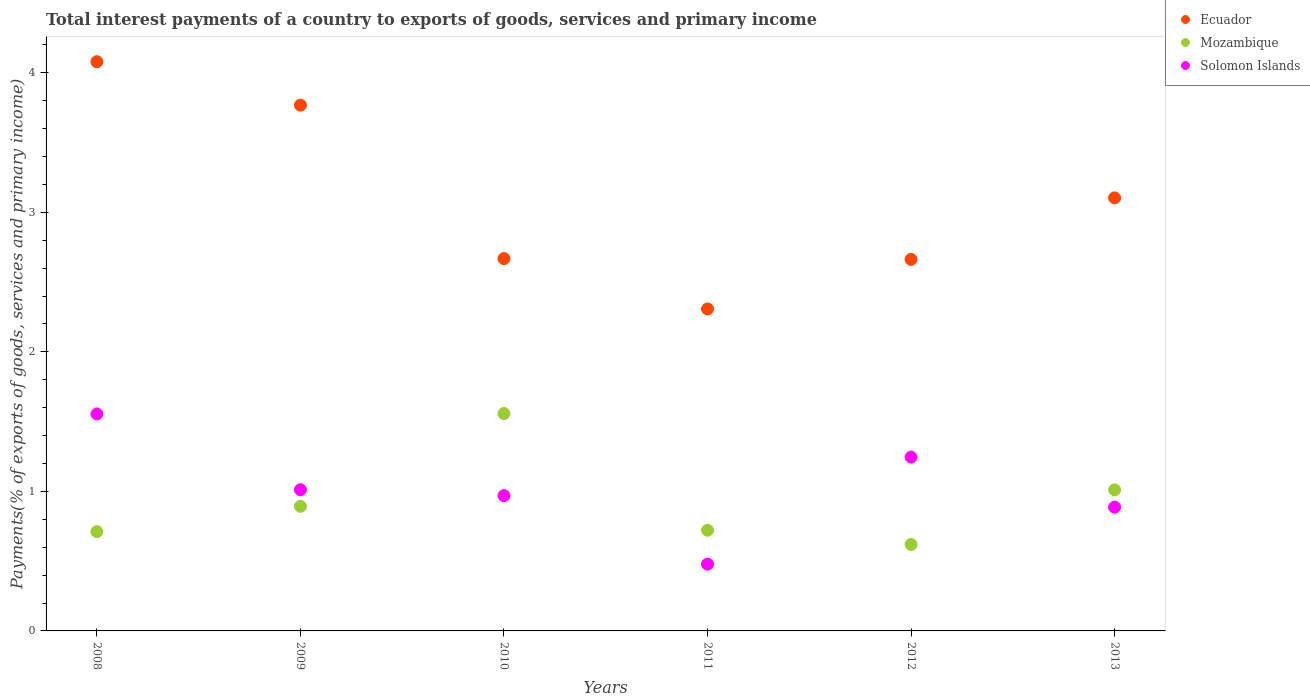Is the number of dotlines equal to the number of legend labels?
Provide a short and direct response. Yes. What is the total interest payments in Mozambique in 2010?
Your answer should be very brief. 1.56. Across all years, what is the maximum total interest payments in Solomon Islands?
Offer a very short reply. 1.56. Across all years, what is the minimum total interest payments in Solomon Islands?
Make the answer very short. 0.48. In which year was the total interest payments in Mozambique maximum?
Your answer should be compact. 2010. What is the total total interest payments in Solomon Islands in the graph?
Provide a short and direct response. 6.15. What is the difference between the total interest payments in Ecuador in 2010 and that in 2012?
Your answer should be very brief. 0.01. What is the difference between the total interest payments in Ecuador in 2009 and the total interest payments in Mozambique in 2012?
Give a very brief answer. 3.15. What is the average total interest payments in Mozambique per year?
Give a very brief answer. 0.92. In the year 2013, what is the difference between the total interest payments in Mozambique and total interest payments in Ecuador?
Provide a succinct answer. -2.09. In how many years, is the total interest payments in Mozambique greater than 0.8 %?
Give a very brief answer. 3. What is the ratio of the total interest payments in Ecuador in 2010 to that in 2013?
Your answer should be very brief. 0.86. Is the total interest payments in Ecuador in 2008 less than that in 2011?
Offer a terse response. No. Is the difference between the total interest payments in Mozambique in 2011 and 2013 greater than the difference between the total interest payments in Ecuador in 2011 and 2013?
Offer a terse response. Yes. What is the difference between the highest and the second highest total interest payments in Solomon Islands?
Keep it short and to the point. 0.31. What is the difference between the highest and the lowest total interest payments in Mozambique?
Your answer should be compact. 0.94. In how many years, is the total interest payments in Mozambique greater than the average total interest payments in Mozambique taken over all years?
Provide a short and direct response. 2. Is the sum of the total interest payments in Solomon Islands in 2008 and 2013 greater than the maximum total interest payments in Mozambique across all years?
Provide a short and direct response. Yes. Is the total interest payments in Solomon Islands strictly greater than the total interest payments in Ecuador over the years?
Keep it short and to the point. No. How many dotlines are there?
Provide a short and direct response. 3. How many years are there in the graph?
Offer a terse response. 6. Are the values on the major ticks of Y-axis written in scientific E-notation?
Ensure brevity in your answer.  No. Does the graph contain any zero values?
Provide a succinct answer. No. Where does the legend appear in the graph?
Offer a terse response. Top right. What is the title of the graph?
Ensure brevity in your answer.  Total interest payments of a country to exports of goods, services and primary income. What is the label or title of the Y-axis?
Provide a succinct answer. Payments(% of exports of goods, services and primary income). What is the Payments(% of exports of goods, services and primary income) of Ecuador in 2008?
Provide a succinct answer. 4.08. What is the Payments(% of exports of goods, services and primary income) of Mozambique in 2008?
Your response must be concise. 0.71. What is the Payments(% of exports of goods, services and primary income) in Solomon Islands in 2008?
Ensure brevity in your answer.  1.56. What is the Payments(% of exports of goods, services and primary income) in Ecuador in 2009?
Offer a terse response. 3.77. What is the Payments(% of exports of goods, services and primary income) in Mozambique in 2009?
Your answer should be very brief. 0.89. What is the Payments(% of exports of goods, services and primary income) of Solomon Islands in 2009?
Keep it short and to the point. 1.01. What is the Payments(% of exports of goods, services and primary income) in Ecuador in 2010?
Keep it short and to the point. 2.67. What is the Payments(% of exports of goods, services and primary income) in Mozambique in 2010?
Your answer should be compact. 1.56. What is the Payments(% of exports of goods, services and primary income) of Solomon Islands in 2010?
Give a very brief answer. 0.97. What is the Payments(% of exports of goods, services and primary income) in Ecuador in 2011?
Offer a terse response. 2.31. What is the Payments(% of exports of goods, services and primary income) in Mozambique in 2011?
Give a very brief answer. 0.72. What is the Payments(% of exports of goods, services and primary income) of Solomon Islands in 2011?
Offer a terse response. 0.48. What is the Payments(% of exports of goods, services and primary income) of Ecuador in 2012?
Provide a succinct answer. 2.66. What is the Payments(% of exports of goods, services and primary income) in Mozambique in 2012?
Offer a very short reply. 0.62. What is the Payments(% of exports of goods, services and primary income) in Solomon Islands in 2012?
Make the answer very short. 1.25. What is the Payments(% of exports of goods, services and primary income) in Ecuador in 2013?
Provide a succinct answer. 3.1. What is the Payments(% of exports of goods, services and primary income) of Mozambique in 2013?
Your answer should be very brief. 1.01. What is the Payments(% of exports of goods, services and primary income) in Solomon Islands in 2013?
Offer a very short reply. 0.89. Across all years, what is the maximum Payments(% of exports of goods, services and primary income) of Ecuador?
Keep it short and to the point. 4.08. Across all years, what is the maximum Payments(% of exports of goods, services and primary income) of Mozambique?
Offer a terse response. 1.56. Across all years, what is the maximum Payments(% of exports of goods, services and primary income) of Solomon Islands?
Provide a succinct answer. 1.56. Across all years, what is the minimum Payments(% of exports of goods, services and primary income) in Ecuador?
Offer a very short reply. 2.31. Across all years, what is the minimum Payments(% of exports of goods, services and primary income) of Mozambique?
Provide a succinct answer. 0.62. Across all years, what is the minimum Payments(% of exports of goods, services and primary income) in Solomon Islands?
Give a very brief answer. 0.48. What is the total Payments(% of exports of goods, services and primary income) in Ecuador in the graph?
Give a very brief answer. 18.59. What is the total Payments(% of exports of goods, services and primary income) of Mozambique in the graph?
Your answer should be very brief. 5.51. What is the total Payments(% of exports of goods, services and primary income) in Solomon Islands in the graph?
Provide a succinct answer. 6.15. What is the difference between the Payments(% of exports of goods, services and primary income) of Ecuador in 2008 and that in 2009?
Your response must be concise. 0.31. What is the difference between the Payments(% of exports of goods, services and primary income) in Mozambique in 2008 and that in 2009?
Offer a very short reply. -0.18. What is the difference between the Payments(% of exports of goods, services and primary income) of Solomon Islands in 2008 and that in 2009?
Make the answer very short. 0.54. What is the difference between the Payments(% of exports of goods, services and primary income) in Ecuador in 2008 and that in 2010?
Make the answer very short. 1.41. What is the difference between the Payments(% of exports of goods, services and primary income) in Mozambique in 2008 and that in 2010?
Offer a very short reply. -0.85. What is the difference between the Payments(% of exports of goods, services and primary income) in Solomon Islands in 2008 and that in 2010?
Ensure brevity in your answer.  0.59. What is the difference between the Payments(% of exports of goods, services and primary income) in Ecuador in 2008 and that in 2011?
Provide a short and direct response. 1.77. What is the difference between the Payments(% of exports of goods, services and primary income) of Mozambique in 2008 and that in 2011?
Provide a succinct answer. -0.01. What is the difference between the Payments(% of exports of goods, services and primary income) of Solomon Islands in 2008 and that in 2011?
Offer a terse response. 1.08. What is the difference between the Payments(% of exports of goods, services and primary income) in Ecuador in 2008 and that in 2012?
Offer a terse response. 1.42. What is the difference between the Payments(% of exports of goods, services and primary income) of Mozambique in 2008 and that in 2012?
Ensure brevity in your answer.  0.09. What is the difference between the Payments(% of exports of goods, services and primary income) of Solomon Islands in 2008 and that in 2012?
Your answer should be compact. 0.31. What is the difference between the Payments(% of exports of goods, services and primary income) in Mozambique in 2008 and that in 2013?
Make the answer very short. -0.3. What is the difference between the Payments(% of exports of goods, services and primary income) of Solomon Islands in 2008 and that in 2013?
Your answer should be very brief. 0.67. What is the difference between the Payments(% of exports of goods, services and primary income) of Ecuador in 2009 and that in 2010?
Provide a succinct answer. 1.1. What is the difference between the Payments(% of exports of goods, services and primary income) in Mozambique in 2009 and that in 2010?
Your answer should be very brief. -0.67. What is the difference between the Payments(% of exports of goods, services and primary income) of Solomon Islands in 2009 and that in 2010?
Your answer should be compact. 0.04. What is the difference between the Payments(% of exports of goods, services and primary income) in Ecuador in 2009 and that in 2011?
Your answer should be very brief. 1.46. What is the difference between the Payments(% of exports of goods, services and primary income) in Mozambique in 2009 and that in 2011?
Your response must be concise. 0.17. What is the difference between the Payments(% of exports of goods, services and primary income) in Solomon Islands in 2009 and that in 2011?
Provide a short and direct response. 0.53. What is the difference between the Payments(% of exports of goods, services and primary income) of Ecuador in 2009 and that in 2012?
Offer a terse response. 1.11. What is the difference between the Payments(% of exports of goods, services and primary income) in Mozambique in 2009 and that in 2012?
Provide a short and direct response. 0.27. What is the difference between the Payments(% of exports of goods, services and primary income) in Solomon Islands in 2009 and that in 2012?
Provide a succinct answer. -0.23. What is the difference between the Payments(% of exports of goods, services and primary income) of Ecuador in 2009 and that in 2013?
Give a very brief answer. 0.66. What is the difference between the Payments(% of exports of goods, services and primary income) in Mozambique in 2009 and that in 2013?
Make the answer very short. -0.12. What is the difference between the Payments(% of exports of goods, services and primary income) of Solomon Islands in 2009 and that in 2013?
Your response must be concise. 0.12. What is the difference between the Payments(% of exports of goods, services and primary income) of Ecuador in 2010 and that in 2011?
Your answer should be compact. 0.36. What is the difference between the Payments(% of exports of goods, services and primary income) of Mozambique in 2010 and that in 2011?
Make the answer very short. 0.84. What is the difference between the Payments(% of exports of goods, services and primary income) in Solomon Islands in 2010 and that in 2011?
Provide a succinct answer. 0.49. What is the difference between the Payments(% of exports of goods, services and primary income) of Ecuador in 2010 and that in 2012?
Your answer should be compact. 0.01. What is the difference between the Payments(% of exports of goods, services and primary income) of Mozambique in 2010 and that in 2012?
Keep it short and to the point. 0.94. What is the difference between the Payments(% of exports of goods, services and primary income) in Solomon Islands in 2010 and that in 2012?
Offer a terse response. -0.28. What is the difference between the Payments(% of exports of goods, services and primary income) in Ecuador in 2010 and that in 2013?
Give a very brief answer. -0.44. What is the difference between the Payments(% of exports of goods, services and primary income) of Mozambique in 2010 and that in 2013?
Keep it short and to the point. 0.55. What is the difference between the Payments(% of exports of goods, services and primary income) in Solomon Islands in 2010 and that in 2013?
Provide a short and direct response. 0.08. What is the difference between the Payments(% of exports of goods, services and primary income) of Ecuador in 2011 and that in 2012?
Make the answer very short. -0.36. What is the difference between the Payments(% of exports of goods, services and primary income) in Mozambique in 2011 and that in 2012?
Offer a very short reply. 0.1. What is the difference between the Payments(% of exports of goods, services and primary income) in Solomon Islands in 2011 and that in 2012?
Make the answer very short. -0.77. What is the difference between the Payments(% of exports of goods, services and primary income) in Ecuador in 2011 and that in 2013?
Keep it short and to the point. -0.8. What is the difference between the Payments(% of exports of goods, services and primary income) of Mozambique in 2011 and that in 2013?
Offer a very short reply. -0.29. What is the difference between the Payments(% of exports of goods, services and primary income) of Solomon Islands in 2011 and that in 2013?
Ensure brevity in your answer.  -0.41. What is the difference between the Payments(% of exports of goods, services and primary income) of Ecuador in 2012 and that in 2013?
Provide a short and direct response. -0.44. What is the difference between the Payments(% of exports of goods, services and primary income) of Mozambique in 2012 and that in 2013?
Give a very brief answer. -0.39. What is the difference between the Payments(% of exports of goods, services and primary income) of Solomon Islands in 2012 and that in 2013?
Provide a succinct answer. 0.36. What is the difference between the Payments(% of exports of goods, services and primary income) in Ecuador in 2008 and the Payments(% of exports of goods, services and primary income) in Mozambique in 2009?
Your answer should be compact. 3.19. What is the difference between the Payments(% of exports of goods, services and primary income) of Ecuador in 2008 and the Payments(% of exports of goods, services and primary income) of Solomon Islands in 2009?
Ensure brevity in your answer.  3.07. What is the difference between the Payments(% of exports of goods, services and primary income) of Mozambique in 2008 and the Payments(% of exports of goods, services and primary income) of Solomon Islands in 2009?
Ensure brevity in your answer.  -0.3. What is the difference between the Payments(% of exports of goods, services and primary income) of Ecuador in 2008 and the Payments(% of exports of goods, services and primary income) of Mozambique in 2010?
Your answer should be compact. 2.52. What is the difference between the Payments(% of exports of goods, services and primary income) in Ecuador in 2008 and the Payments(% of exports of goods, services and primary income) in Solomon Islands in 2010?
Your response must be concise. 3.11. What is the difference between the Payments(% of exports of goods, services and primary income) in Mozambique in 2008 and the Payments(% of exports of goods, services and primary income) in Solomon Islands in 2010?
Make the answer very short. -0.26. What is the difference between the Payments(% of exports of goods, services and primary income) of Ecuador in 2008 and the Payments(% of exports of goods, services and primary income) of Mozambique in 2011?
Provide a succinct answer. 3.36. What is the difference between the Payments(% of exports of goods, services and primary income) in Ecuador in 2008 and the Payments(% of exports of goods, services and primary income) in Solomon Islands in 2011?
Offer a terse response. 3.6. What is the difference between the Payments(% of exports of goods, services and primary income) of Mozambique in 2008 and the Payments(% of exports of goods, services and primary income) of Solomon Islands in 2011?
Ensure brevity in your answer.  0.23. What is the difference between the Payments(% of exports of goods, services and primary income) of Ecuador in 2008 and the Payments(% of exports of goods, services and primary income) of Mozambique in 2012?
Ensure brevity in your answer.  3.46. What is the difference between the Payments(% of exports of goods, services and primary income) in Ecuador in 2008 and the Payments(% of exports of goods, services and primary income) in Solomon Islands in 2012?
Keep it short and to the point. 2.83. What is the difference between the Payments(% of exports of goods, services and primary income) of Mozambique in 2008 and the Payments(% of exports of goods, services and primary income) of Solomon Islands in 2012?
Your response must be concise. -0.53. What is the difference between the Payments(% of exports of goods, services and primary income) of Ecuador in 2008 and the Payments(% of exports of goods, services and primary income) of Mozambique in 2013?
Ensure brevity in your answer.  3.07. What is the difference between the Payments(% of exports of goods, services and primary income) of Ecuador in 2008 and the Payments(% of exports of goods, services and primary income) of Solomon Islands in 2013?
Offer a terse response. 3.19. What is the difference between the Payments(% of exports of goods, services and primary income) of Mozambique in 2008 and the Payments(% of exports of goods, services and primary income) of Solomon Islands in 2013?
Provide a succinct answer. -0.18. What is the difference between the Payments(% of exports of goods, services and primary income) of Ecuador in 2009 and the Payments(% of exports of goods, services and primary income) of Mozambique in 2010?
Offer a very short reply. 2.21. What is the difference between the Payments(% of exports of goods, services and primary income) of Ecuador in 2009 and the Payments(% of exports of goods, services and primary income) of Solomon Islands in 2010?
Offer a terse response. 2.8. What is the difference between the Payments(% of exports of goods, services and primary income) of Mozambique in 2009 and the Payments(% of exports of goods, services and primary income) of Solomon Islands in 2010?
Offer a terse response. -0.08. What is the difference between the Payments(% of exports of goods, services and primary income) in Ecuador in 2009 and the Payments(% of exports of goods, services and primary income) in Mozambique in 2011?
Offer a terse response. 3.05. What is the difference between the Payments(% of exports of goods, services and primary income) of Ecuador in 2009 and the Payments(% of exports of goods, services and primary income) of Solomon Islands in 2011?
Keep it short and to the point. 3.29. What is the difference between the Payments(% of exports of goods, services and primary income) of Mozambique in 2009 and the Payments(% of exports of goods, services and primary income) of Solomon Islands in 2011?
Offer a terse response. 0.41. What is the difference between the Payments(% of exports of goods, services and primary income) in Ecuador in 2009 and the Payments(% of exports of goods, services and primary income) in Mozambique in 2012?
Provide a short and direct response. 3.15. What is the difference between the Payments(% of exports of goods, services and primary income) of Ecuador in 2009 and the Payments(% of exports of goods, services and primary income) of Solomon Islands in 2012?
Provide a short and direct response. 2.52. What is the difference between the Payments(% of exports of goods, services and primary income) in Mozambique in 2009 and the Payments(% of exports of goods, services and primary income) in Solomon Islands in 2012?
Your response must be concise. -0.35. What is the difference between the Payments(% of exports of goods, services and primary income) in Ecuador in 2009 and the Payments(% of exports of goods, services and primary income) in Mozambique in 2013?
Offer a terse response. 2.76. What is the difference between the Payments(% of exports of goods, services and primary income) in Ecuador in 2009 and the Payments(% of exports of goods, services and primary income) in Solomon Islands in 2013?
Provide a succinct answer. 2.88. What is the difference between the Payments(% of exports of goods, services and primary income) of Mozambique in 2009 and the Payments(% of exports of goods, services and primary income) of Solomon Islands in 2013?
Offer a very short reply. 0.01. What is the difference between the Payments(% of exports of goods, services and primary income) in Ecuador in 2010 and the Payments(% of exports of goods, services and primary income) in Mozambique in 2011?
Provide a succinct answer. 1.95. What is the difference between the Payments(% of exports of goods, services and primary income) in Ecuador in 2010 and the Payments(% of exports of goods, services and primary income) in Solomon Islands in 2011?
Offer a very short reply. 2.19. What is the difference between the Payments(% of exports of goods, services and primary income) in Mozambique in 2010 and the Payments(% of exports of goods, services and primary income) in Solomon Islands in 2011?
Your answer should be compact. 1.08. What is the difference between the Payments(% of exports of goods, services and primary income) of Ecuador in 2010 and the Payments(% of exports of goods, services and primary income) of Mozambique in 2012?
Ensure brevity in your answer.  2.05. What is the difference between the Payments(% of exports of goods, services and primary income) of Ecuador in 2010 and the Payments(% of exports of goods, services and primary income) of Solomon Islands in 2012?
Offer a very short reply. 1.42. What is the difference between the Payments(% of exports of goods, services and primary income) of Mozambique in 2010 and the Payments(% of exports of goods, services and primary income) of Solomon Islands in 2012?
Ensure brevity in your answer.  0.31. What is the difference between the Payments(% of exports of goods, services and primary income) in Ecuador in 2010 and the Payments(% of exports of goods, services and primary income) in Mozambique in 2013?
Offer a very short reply. 1.66. What is the difference between the Payments(% of exports of goods, services and primary income) in Ecuador in 2010 and the Payments(% of exports of goods, services and primary income) in Solomon Islands in 2013?
Keep it short and to the point. 1.78. What is the difference between the Payments(% of exports of goods, services and primary income) of Mozambique in 2010 and the Payments(% of exports of goods, services and primary income) of Solomon Islands in 2013?
Give a very brief answer. 0.67. What is the difference between the Payments(% of exports of goods, services and primary income) in Ecuador in 2011 and the Payments(% of exports of goods, services and primary income) in Mozambique in 2012?
Your response must be concise. 1.69. What is the difference between the Payments(% of exports of goods, services and primary income) of Ecuador in 2011 and the Payments(% of exports of goods, services and primary income) of Solomon Islands in 2012?
Offer a terse response. 1.06. What is the difference between the Payments(% of exports of goods, services and primary income) in Mozambique in 2011 and the Payments(% of exports of goods, services and primary income) in Solomon Islands in 2012?
Ensure brevity in your answer.  -0.52. What is the difference between the Payments(% of exports of goods, services and primary income) in Ecuador in 2011 and the Payments(% of exports of goods, services and primary income) in Mozambique in 2013?
Give a very brief answer. 1.3. What is the difference between the Payments(% of exports of goods, services and primary income) of Ecuador in 2011 and the Payments(% of exports of goods, services and primary income) of Solomon Islands in 2013?
Keep it short and to the point. 1.42. What is the difference between the Payments(% of exports of goods, services and primary income) in Mozambique in 2011 and the Payments(% of exports of goods, services and primary income) in Solomon Islands in 2013?
Keep it short and to the point. -0.17. What is the difference between the Payments(% of exports of goods, services and primary income) in Ecuador in 2012 and the Payments(% of exports of goods, services and primary income) in Mozambique in 2013?
Your response must be concise. 1.65. What is the difference between the Payments(% of exports of goods, services and primary income) in Ecuador in 2012 and the Payments(% of exports of goods, services and primary income) in Solomon Islands in 2013?
Ensure brevity in your answer.  1.78. What is the difference between the Payments(% of exports of goods, services and primary income) of Mozambique in 2012 and the Payments(% of exports of goods, services and primary income) of Solomon Islands in 2013?
Make the answer very short. -0.27. What is the average Payments(% of exports of goods, services and primary income) in Ecuador per year?
Offer a very short reply. 3.1. What is the average Payments(% of exports of goods, services and primary income) in Mozambique per year?
Your answer should be compact. 0.92. What is the average Payments(% of exports of goods, services and primary income) in Solomon Islands per year?
Give a very brief answer. 1.02. In the year 2008, what is the difference between the Payments(% of exports of goods, services and primary income) of Ecuador and Payments(% of exports of goods, services and primary income) of Mozambique?
Your answer should be very brief. 3.37. In the year 2008, what is the difference between the Payments(% of exports of goods, services and primary income) of Ecuador and Payments(% of exports of goods, services and primary income) of Solomon Islands?
Give a very brief answer. 2.52. In the year 2008, what is the difference between the Payments(% of exports of goods, services and primary income) of Mozambique and Payments(% of exports of goods, services and primary income) of Solomon Islands?
Offer a terse response. -0.84. In the year 2009, what is the difference between the Payments(% of exports of goods, services and primary income) of Ecuador and Payments(% of exports of goods, services and primary income) of Mozambique?
Offer a very short reply. 2.88. In the year 2009, what is the difference between the Payments(% of exports of goods, services and primary income) in Ecuador and Payments(% of exports of goods, services and primary income) in Solomon Islands?
Ensure brevity in your answer.  2.76. In the year 2009, what is the difference between the Payments(% of exports of goods, services and primary income) of Mozambique and Payments(% of exports of goods, services and primary income) of Solomon Islands?
Offer a very short reply. -0.12. In the year 2010, what is the difference between the Payments(% of exports of goods, services and primary income) in Ecuador and Payments(% of exports of goods, services and primary income) in Mozambique?
Ensure brevity in your answer.  1.11. In the year 2010, what is the difference between the Payments(% of exports of goods, services and primary income) in Ecuador and Payments(% of exports of goods, services and primary income) in Solomon Islands?
Provide a succinct answer. 1.7. In the year 2010, what is the difference between the Payments(% of exports of goods, services and primary income) in Mozambique and Payments(% of exports of goods, services and primary income) in Solomon Islands?
Give a very brief answer. 0.59. In the year 2011, what is the difference between the Payments(% of exports of goods, services and primary income) in Ecuador and Payments(% of exports of goods, services and primary income) in Mozambique?
Your response must be concise. 1.59. In the year 2011, what is the difference between the Payments(% of exports of goods, services and primary income) of Ecuador and Payments(% of exports of goods, services and primary income) of Solomon Islands?
Your response must be concise. 1.83. In the year 2011, what is the difference between the Payments(% of exports of goods, services and primary income) in Mozambique and Payments(% of exports of goods, services and primary income) in Solomon Islands?
Ensure brevity in your answer.  0.24. In the year 2012, what is the difference between the Payments(% of exports of goods, services and primary income) in Ecuador and Payments(% of exports of goods, services and primary income) in Mozambique?
Your response must be concise. 2.04. In the year 2012, what is the difference between the Payments(% of exports of goods, services and primary income) of Ecuador and Payments(% of exports of goods, services and primary income) of Solomon Islands?
Provide a short and direct response. 1.42. In the year 2012, what is the difference between the Payments(% of exports of goods, services and primary income) of Mozambique and Payments(% of exports of goods, services and primary income) of Solomon Islands?
Give a very brief answer. -0.63. In the year 2013, what is the difference between the Payments(% of exports of goods, services and primary income) in Ecuador and Payments(% of exports of goods, services and primary income) in Mozambique?
Provide a succinct answer. 2.09. In the year 2013, what is the difference between the Payments(% of exports of goods, services and primary income) of Ecuador and Payments(% of exports of goods, services and primary income) of Solomon Islands?
Ensure brevity in your answer.  2.22. In the year 2013, what is the difference between the Payments(% of exports of goods, services and primary income) of Mozambique and Payments(% of exports of goods, services and primary income) of Solomon Islands?
Your answer should be compact. 0.12. What is the ratio of the Payments(% of exports of goods, services and primary income) of Ecuador in 2008 to that in 2009?
Provide a succinct answer. 1.08. What is the ratio of the Payments(% of exports of goods, services and primary income) in Mozambique in 2008 to that in 2009?
Provide a succinct answer. 0.8. What is the ratio of the Payments(% of exports of goods, services and primary income) in Solomon Islands in 2008 to that in 2009?
Your answer should be very brief. 1.54. What is the ratio of the Payments(% of exports of goods, services and primary income) in Ecuador in 2008 to that in 2010?
Your answer should be compact. 1.53. What is the ratio of the Payments(% of exports of goods, services and primary income) in Mozambique in 2008 to that in 2010?
Make the answer very short. 0.46. What is the ratio of the Payments(% of exports of goods, services and primary income) in Solomon Islands in 2008 to that in 2010?
Give a very brief answer. 1.6. What is the ratio of the Payments(% of exports of goods, services and primary income) of Ecuador in 2008 to that in 2011?
Make the answer very short. 1.77. What is the ratio of the Payments(% of exports of goods, services and primary income) in Mozambique in 2008 to that in 2011?
Your answer should be compact. 0.99. What is the ratio of the Payments(% of exports of goods, services and primary income) in Solomon Islands in 2008 to that in 2011?
Your answer should be very brief. 3.25. What is the ratio of the Payments(% of exports of goods, services and primary income) in Ecuador in 2008 to that in 2012?
Provide a short and direct response. 1.53. What is the ratio of the Payments(% of exports of goods, services and primary income) in Mozambique in 2008 to that in 2012?
Make the answer very short. 1.15. What is the ratio of the Payments(% of exports of goods, services and primary income) of Solomon Islands in 2008 to that in 2012?
Offer a very short reply. 1.25. What is the ratio of the Payments(% of exports of goods, services and primary income) of Ecuador in 2008 to that in 2013?
Your answer should be very brief. 1.31. What is the ratio of the Payments(% of exports of goods, services and primary income) of Mozambique in 2008 to that in 2013?
Your answer should be very brief. 0.7. What is the ratio of the Payments(% of exports of goods, services and primary income) of Solomon Islands in 2008 to that in 2013?
Make the answer very short. 1.75. What is the ratio of the Payments(% of exports of goods, services and primary income) of Ecuador in 2009 to that in 2010?
Offer a terse response. 1.41. What is the ratio of the Payments(% of exports of goods, services and primary income) in Mozambique in 2009 to that in 2010?
Offer a very short reply. 0.57. What is the ratio of the Payments(% of exports of goods, services and primary income) in Solomon Islands in 2009 to that in 2010?
Provide a short and direct response. 1.04. What is the ratio of the Payments(% of exports of goods, services and primary income) of Ecuador in 2009 to that in 2011?
Your answer should be very brief. 1.63. What is the ratio of the Payments(% of exports of goods, services and primary income) of Mozambique in 2009 to that in 2011?
Provide a succinct answer. 1.24. What is the ratio of the Payments(% of exports of goods, services and primary income) of Solomon Islands in 2009 to that in 2011?
Your answer should be very brief. 2.11. What is the ratio of the Payments(% of exports of goods, services and primary income) of Ecuador in 2009 to that in 2012?
Offer a terse response. 1.42. What is the ratio of the Payments(% of exports of goods, services and primary income) of Mozambique in 2009 to that in 2012?
Keep it short and to the point. 1.44. What is the ratio of the Payments(% of exports of goods, services and primary income) in Solomon Islands in 2009 to that in 2012?
Keep it short and to the point. 0.81. What is the ratio of the Payments(% of exports of goods, services and primary income) of Ecuador in 2009 to that in 2013?
Keep it short and to the point. 1.21. What is the ratio of the Payments(% of exports of goods, services and primary income) of Mozambique in 2009 to that in 2013?
Your answer should be very brief. 0.88. What is the ratio of the Payments(% of exports of goods, services and primary income) of Solomon Islands in 2009 to that in 2013?
Your response must be concise. 1.14. What is the ratio of the Payments(% of exports of goods, services and primary income) of Ecuador in 2010 to that in 2011?
Ensure brevity in your answer.  1.16. What is the ratio of the Payments(% of exports of goods, services and primary income) in Mozambique in 2010 to that in 2011?
Provide a succinct answer. 2.16. What is the ratio of the Payments(% of exports of goods, services and primary income) in Solomon Islands in 2010 to that in 2011?
Provide a succinct answer. 2.03. What is the ratio of the Payments(% of exports of goods, services and primary income) of Ecuador in 2010 to that in 2012?
Provide a succinct answer. 1. What is the ratio of the Payments(% of exports of goods, services and primary income) in Mozambique in 2010 to that in 2012?
Ensure brevity in your answer.  2.52. What is the ratio of the Payments(% of exports of goods, services and primary income) in Solomon Islands in 2010 to that in 2012?
Offer a terse response. 0.78. What is the ratio of the Payments(% of exports of goods, services and primary income) in Ecuador in 2010 to that in 2013?
Your answer should be compact. 0.86. What is the ratio of the Payments(% of exports of goods, services and primary income) in Mozambique in 2010 to that in 2013?
Provide a short and direct response. 1.54. What is the ratio of the Payments(% of exports of goods, services and primary income) of Solomon Islands in 2010 to that in 2013?
Make the answer very short. 1.09. What is the ratio of the Payments(% of exports of goods, services and primary income) in Ecuador in 2011 to that in 2012?
Provide a short and direct response. 0.87. What is the ratio of the Payments(% of exports of goods, services and primary income) in Mozambique in 2011 to that in 2012?
Your answer should be very brief. 1.16. What is the ratio of the Payments(% of exports of goods, services and primary income) of Solomon Islands in 2011 to that in 2012?
Offer a very short reply. 0.38. What is the ratio of the Payments(% of exports of goods, services and primary income) of Ecuador in 2011 to that in 2013?
Offer a terse response. 0.74. What is the ratio of the Payments(% of exports of goods, services and primary income) of Mozambique in 2011 to that in 2013?
Your answer should be compact. 0.71. What is the ratio of the Payments(% of exports of goods, services and primary income) of Solomon Islands in 2011 to that in 2013?
Keep it short and to the point. 0.54. What is the ratio of the Payments(% of exports of goods, services and primary income) in Ecuador in 2012 to that in 2013?
Ensure brevity in your answer.  0.86. What is the ratio of the Payments(% of exports of goods, services and primary income) of Mozambique in 2012 to that in 2013?
Offer a terse response. 0.61. What is the ratio of the Payments(% of exports of goods, services and primary income) in Solomon Islands in 2012 to that in 2013?
Ensure brevity in your answer.  1.4. What is the difference between the highest and the second highest Payments(% of exports of goods, services and primary income) in Ecuador?
Give a very brief answer. 0.31. What is the difference between the highest and the second highest Payments(% of exports of goods, services and primary income) of Mozambique?
Your answer should be very brief. 0.55. What is the difference between the highest and the second highest Payments(% of exports of goods, services and primary income) in Solomon Islands?
Your response must be concise. 0.31. What is the difference between the highest and the lowest Payments(% of exports of goods, services and primary income) in Ecuador?
Your answer should be very brief. 1.77. What is the difference between the highest and the lowest Payments(% of exports of goods, services and primary income) of Mozambique?
Make the answer very short. 0.94. What is the difference between the highest and the lowest Payments(% of exports of goods, services and primary income) in Solomon Islands?
Offer a very short reply. 1.08. 